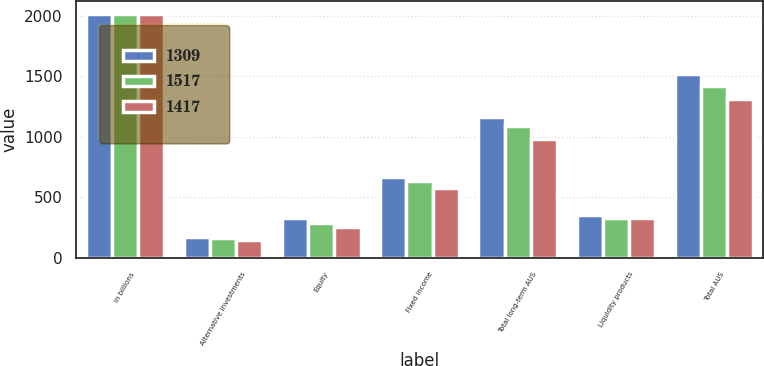Convert chart to OTSL. <chart><loc_0><loc_0><loc_500><loc_500><stacked_bar_chart><ecel><fcel>in billions<fcel>Alternative investments<fcel>Equity<fcel>Fixed income<fcel>Total long-term AUS<fcel>Liquidity products<fcel>Total AUS<nl><fcel>1309<fcel>2018<fcel>171<fcel>329<fcel>665<fcel>1165<fcel>352<fcel>1517<nl><fcel>1517<fcel>2017<fcel>162<fcel>292<fcel>633<fcel>1087<fcel>330<fcel>1417<nl><fcel>1417<fcel>2016<fcel>149<fcel>256<fcel>578<fcel>983<fcel>326<fcel>1309<nl></chart> 